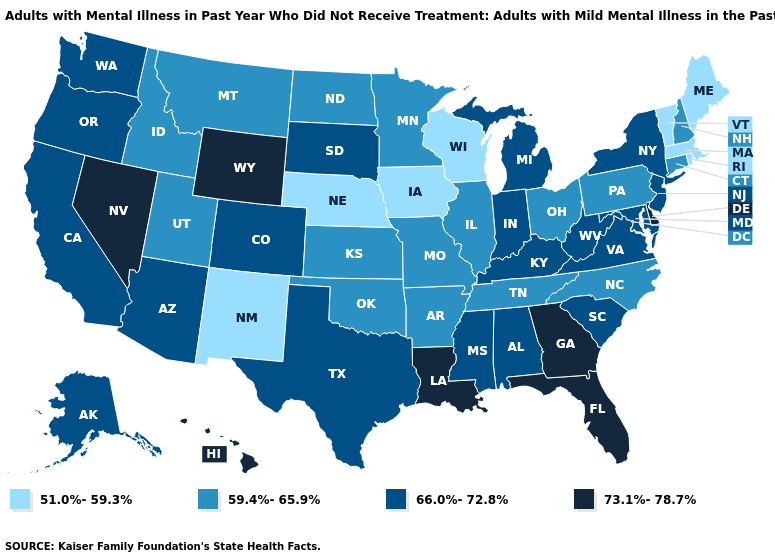What is the value of Mississippi?
Quick response, please. 66.0%-72.8%. Does the map have missing data?
Write a very short answer. No. Which states have the lowest value in the Northeast?
Short answer required. Maine, Massachusetts, Rhode Island, Vermont. Which states have the lowest value in the MidWest?
Keep it brief. Iowa, Nebraska, Wisconsin. Name the states that have a value in the range 66.0%-72.8%?
Quick response, please. Alabama, Alaska, Arizona, California, Colorado, Indiana, Kentucky, Maryland, Michigan, Mississippi, New Jersey, New York, Oregon, South Carolina, South Dakota, Texas, Virginia, Washington, West Virginia. What is the value of Pennsylvania?
Write a very short answer. 59.4%-65.9%. What is the value of Louisiana?
Keep it brief. 73.1%-78.7%. Name the states that have a value in the range 51.0%-59.3%?
Concise answer only. Iowa, Maine, Massachusetts, Nebraska, New Mexico, Rhode Island, Vermont, Wisconsin. What is the value of Tennessee?
Concise answer only. 59.4%-65.9%. What is the lowest value in the West?
Short answer required. 51.0%-59.3%. Does New Jersey have the lowest value in the Northeast?
Keep it brief. No. Among the states that border North Dakota , which have the lowest value?
Write a very short answer. Minnesota, Montana. Name the states that have a value in the range 59.4%-65.9%?
Write a very short answer. Arkansas, Connecticut, Idaho, Illinois, Kansas, Minnesota, Missouri, Montana, New Hampshire, North Carolina, North Dakota, Ohio, Oklahoma, Pennsylvania, Tennessee, Utah. How many symbols are there in the legend?
Write a very short answer. 4. What is the value of Illinois?
Quick response, please. 59.4%-65.9%. 